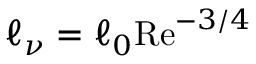<formula> <loc_0><loc_0><loc_500><loc_500>\ell _ { \nu } = \ell _ { 0 } R e ^ { - 3 / 4 }</formula> 